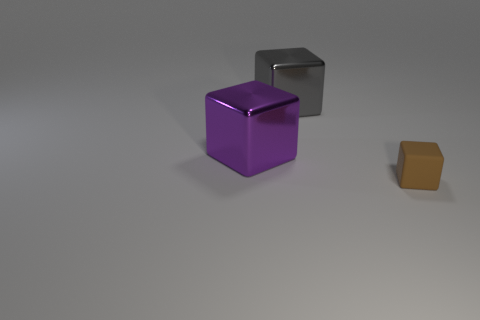Add 2 cyan balls. How many objects exist? 5 Add 2 brown things. How many brown things are left? 3 Add 1 gray objects. How many gray objects exist? 2 Subtract 0 green spheres. How many objects are left? 3 Subtract all small brown cubes. Subtract all purple shiny things. How many objects are left? 1 